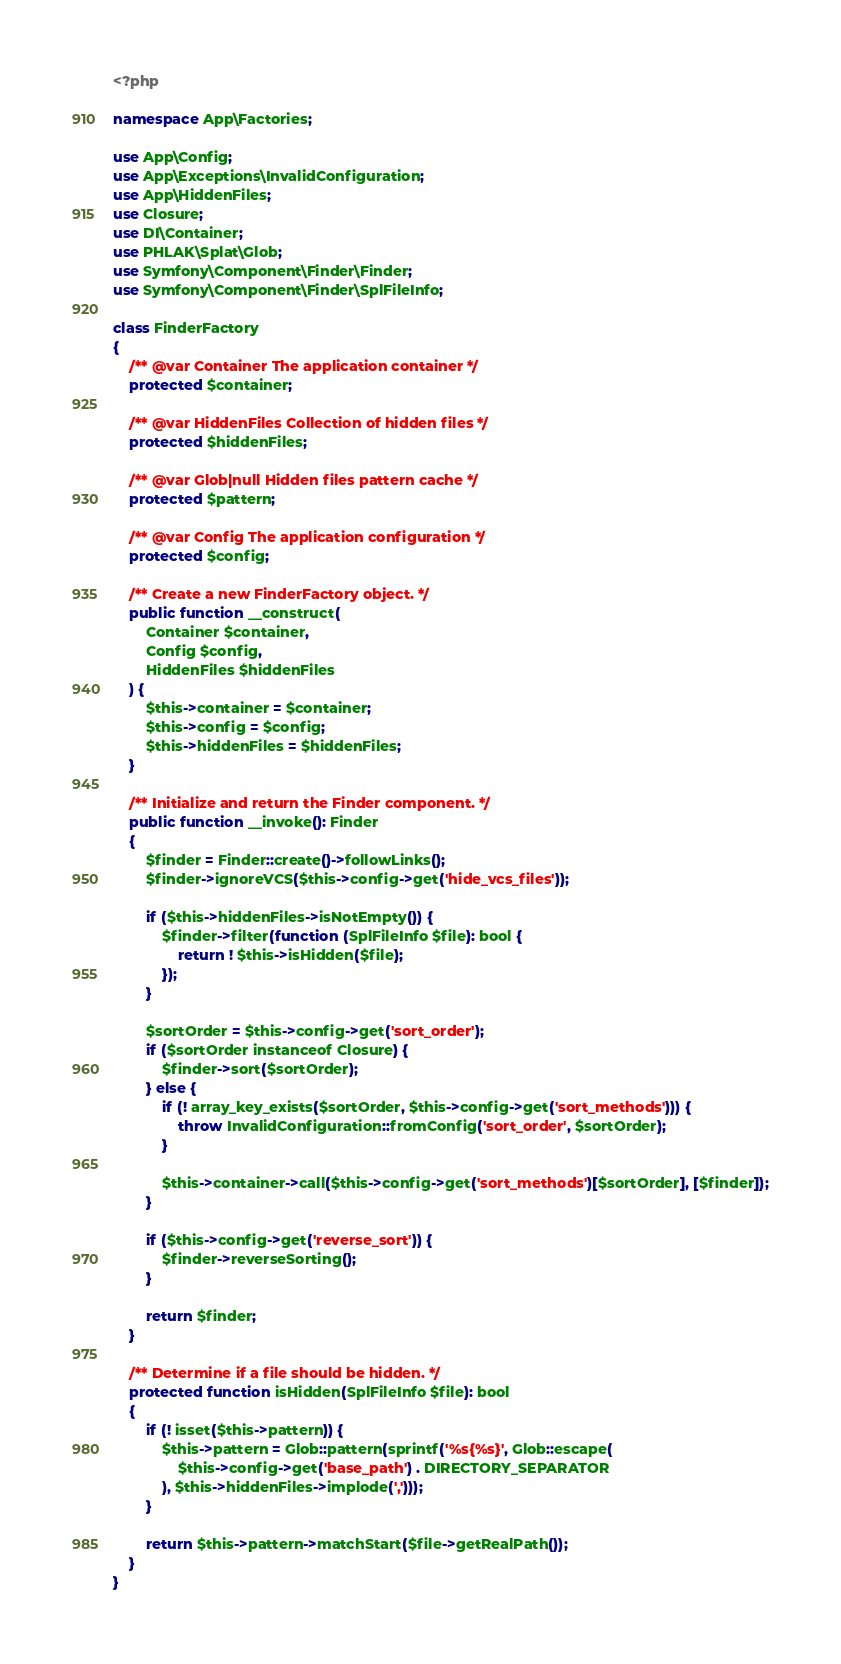Convert code to text. <code><loc_0><loc_0><loc_500><loc_500><_PHP_><?php

namespace App\Factories;

use App\Config;
use App\Exceptions\InvalidConfiguration;
use App\HiddenFiles;
use Closure;
use DI\Container;
use PHLAK\Splat\Glob;
use Symfony\Component\Finder\Finder;
use Symfony\Component\Finder\SplFileInfo;

class FinderFactory
{
    /** @var Container The application container */
    protected $container;

    /** @var HiddenFiles Collection of hidden files */
    protected $hiddenFiles;

    /** @var Glob|null Hidden files pattern cache */
    protected $pattern;

    /** @var Config The application configuration */
    protected $config;

    /** Create a new FinderFactory object. */
    public function __construct(
        Container $container,
        Config $config,
        HiddenFiles $hiddenFiles
    ) {
        $this->container = $container;
        $this->config = $config;
        $this->hiddenFiles = $hiddenFiles;
    }

    /** Initialize and return the Finder component. */
    public function __invoke(): Finder
    {
        $finder = Finder::create()->followLinks();
        $finder->ignoreVCS($this->config->get('hide_vcs_files'));

        if ($this->hiddenFiles->isNotEmpty()) {
            $finder->filter(function (SplFileInfo $file): bool {
                return ! $this->isHidden($file);
            });
        }

        $sortOrder = $this->config->get('sort_order');
        if ($sortOrder instanceof Closure) {
            $finder->sort($sortOrder);
        } else {
            if (! array_key_exists($sortOrder, $this->config->get('sort_methods'))) {
                throw InvalidConfiguration::fromConfig('sort_order', $sortOrder);
            }

            $this->container->call($this->config->get('sort_methods')[$sortOrder], [$finder]);
        }

        if ($this->config->get('reverse_sort')) {
            $finder->reverseSorting();
        }

        return $finder;
    }

    /** Determine if a file should be hidden. */
    protected function isHidden(SplFileInfo $file): bool
    {
        if (! isset($this->pattern)) {
            $this->pattern = Glob::pattern(sprintf('%s{%s}', Glob::escape(
                $this->config->get('base_path') . DIRECTORY_SEPARATOR
            ), $this->hiddenFiles->implode(',')));
        }

        return $this->pattern->matchStart($file->getRealPath());
    }
}
</code> 